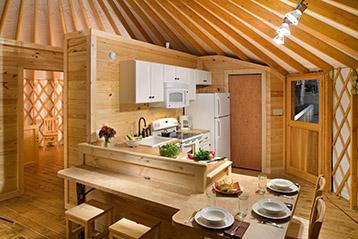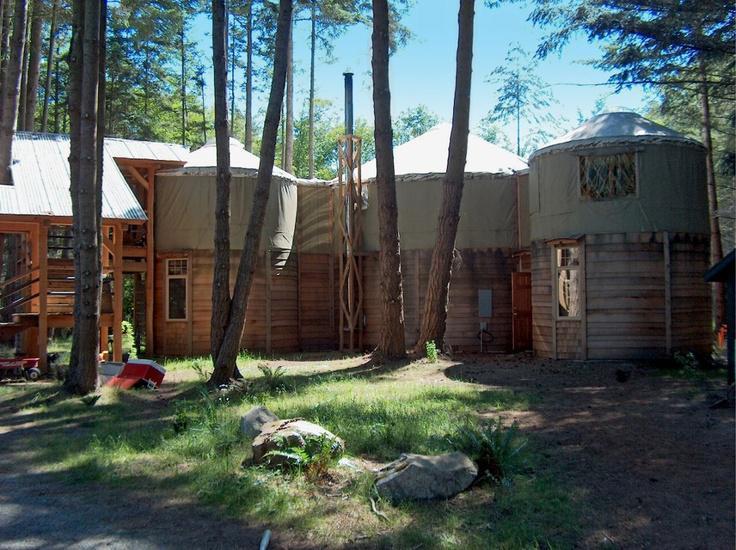The first image is the image on the left, the second image is the image on the right. Considering the images on both sides, is "An image shows an interior with three side-by-side lattice-work dome-topped structural elements visible." valid? Answer yes or no. No. The first image is the image on the left, the second image is the image on the right. Considering the images on both sides, is "One image shows the interior of a large yurt with the framework of three small side-by-side yurts in the rear and a skylight overhead." valid? Answer yes or no. No. 